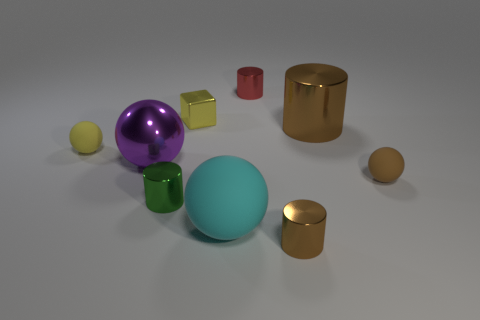What materials do the objects seem to be made of? The objects in the image appear to be made of different materials which give them their unique textures and reflections. The sphere, cylinder, and one of the cubes show a polished metallic finish, suggesting they are metal. The large ball in the center has a matte finish, indicative of a plastic or rubber material. There's also a smaller sphere and cube that share a similar matte finish, suggesting they might be made of the same material. 